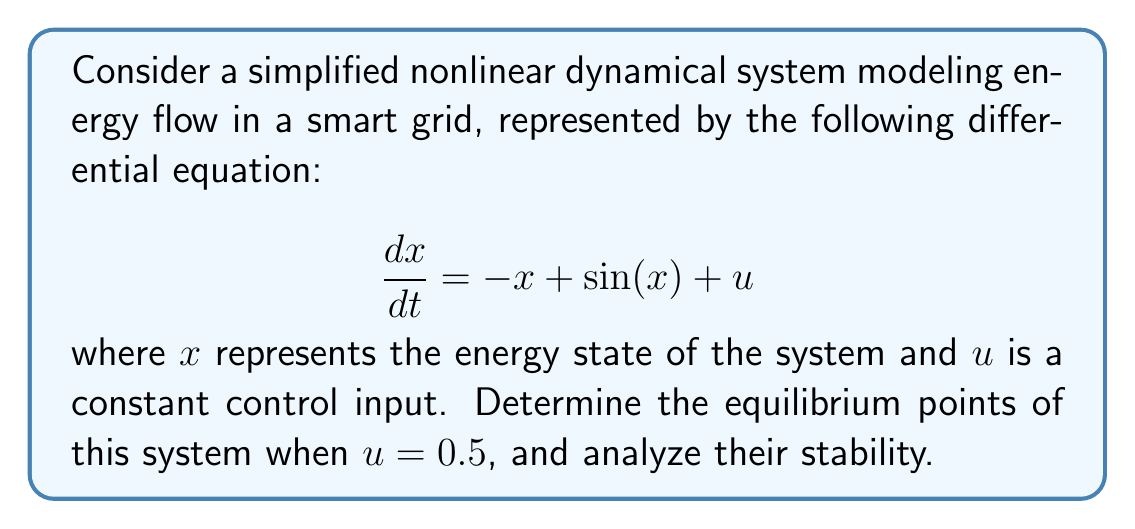Can you answer this question? To solve this problem, we'll follow these steps:

1) Find the equilibrium points:
   Equilibrium points occur when $\frac{dx}{dt} = 0$. So, we solve:
   $$ -x + \sin(x) + 0.5 = 0 $$

   This is a nonlinear equation that can't be solved analytically. We can use graphical or numerical methods to find that there are two equilibrium points:
   $x_1 \approx 0.6745$ and $x_2 \approx 2.6795$

2) Analyze stability:
   To determine stability, we need to evaluate the Jacobian at each equilibrium point:
   $$ J = \frac{\partial}{\partial x}(-x + \sin(x) + 0.5) = -1 + \cos(x) $$

   For $x_1 \approx 0.6745$:
   $J(x_1) \approx -1 + \cos(0.6745) \approx -1.2210 < 0$
   This indicates that $x_1$ is a stable equilibrium point.

   For $x_2 \approx 2.6795$:
   $J(x_2) \approx -1 + \cos(2.6795) \approx 0.2210 > 0$
   This indicates that $x_2$ is an unstable equilibrium point.

3) Phase portrait analysis:
   We can visualize the stability of these equilibrium points using a phase portrait:

   [asy]
   import graph;
   size(200,200);
   
   real f(real x) {return -x + sin(x) + 0.5;}
   
   draw(graph(f,-1,4), blue);
   draw((-1,0)--(4,0), gray);
   draw((0,-1.5)--(0,1.5), gray);
   
   dot((0.6745,0), red);
   dot((2.6795,0), green);
   
   label("Stable", (0.6745,-0.2), S);
   label("Unstable", (2.6795,0.2), N);
   [/asy]

   The phase portrait confirms our stability analysis. The system tends towards the stable equilibrium point at $x_1$ and away from the unstable equilibrium point at $x_2$.
Answer: Two equilibrium points: $x_1 \approx 0.6745$ (stable) and $x_2 \approx 2.6795$ (unstable). 